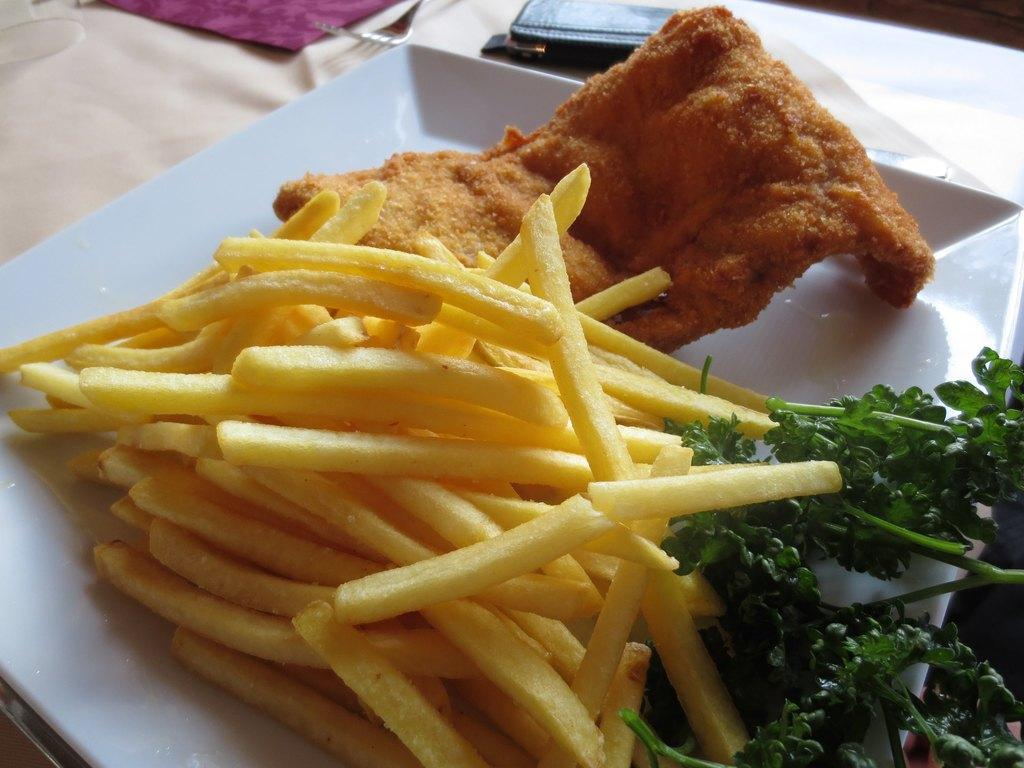What is on the plate in the image? There is food on a plate in the image. What type of material is the cloth made of? The cloth's material cannot be determined from the image. What utensil is visible in the image? There is a fork in the image. Can you describe any other objects in the image? There are other unspecified objects in the image. Where is the faucet located in the image? There is no faucet present in the image. What type of vacation is the couple planning based on the image? The image does not provide any information about a vacation or a couple, so it cannot be determined from the image. 